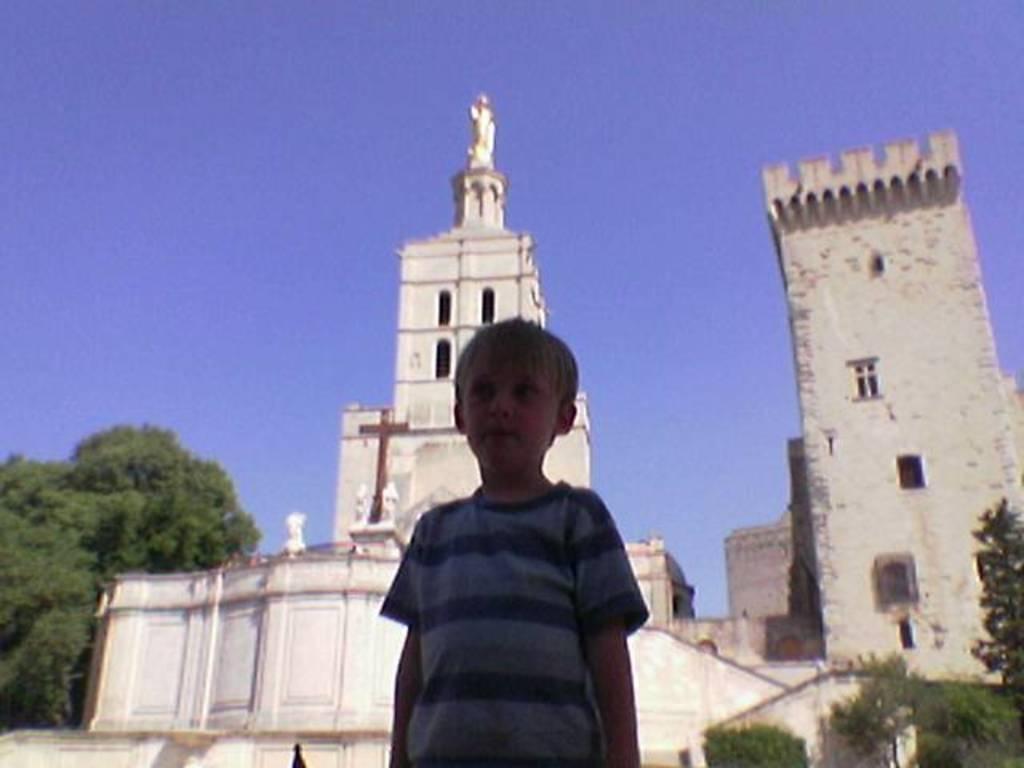Could you give a brief overview of what you see in this image? In this Image I can see the person with blue color dress. In the back there are trees and the buildings which are in white color. In the back there is a blue sky. 